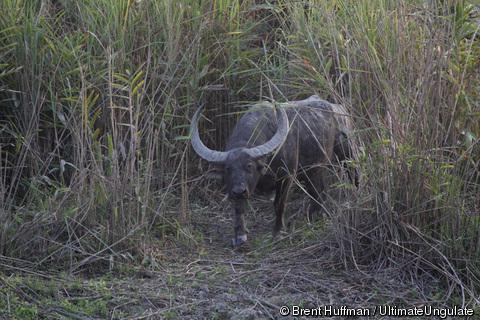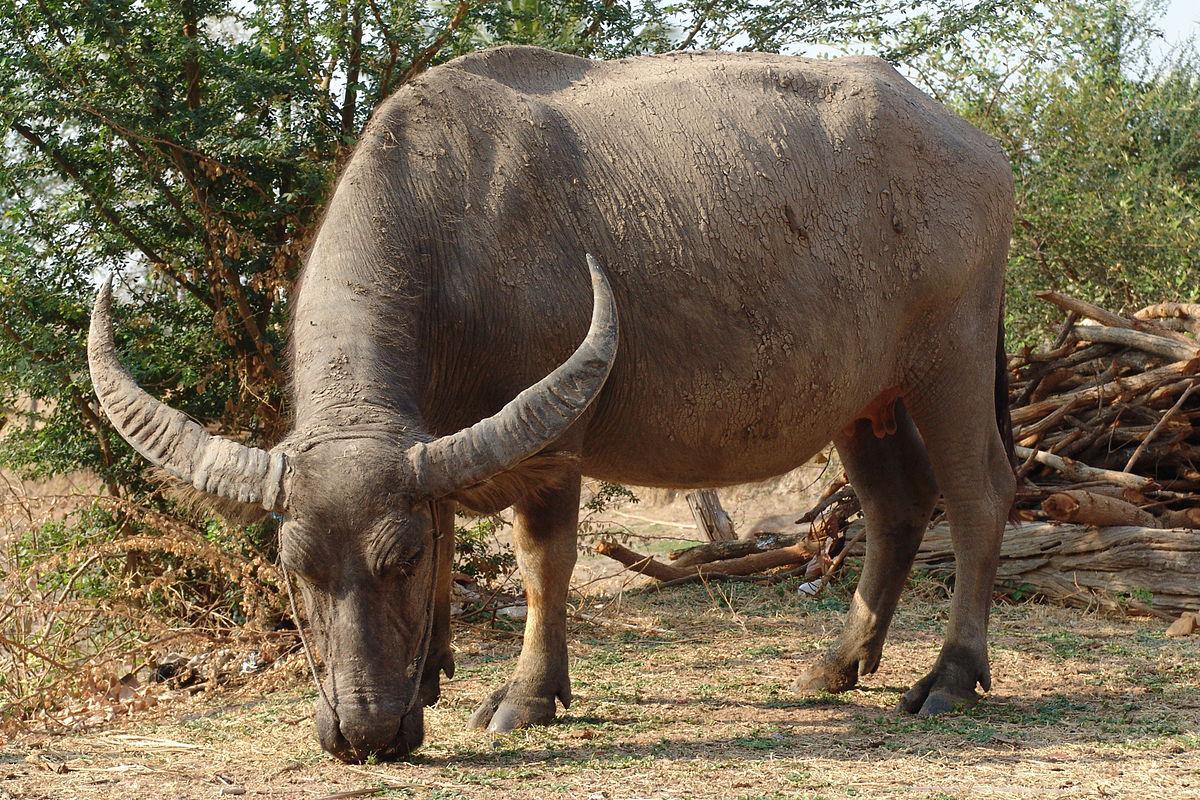The first image is the image on the left, the second image is the image on the right. For the images shown, is this caption "At least 2 cows are standing in the water." true? Answer yes or no. No. The first image is the image on the left, the second image is the image on the right. For the images shown, is this caption "The right image contains exactly one water buffalo." true? Answer yes or no. Yes. 